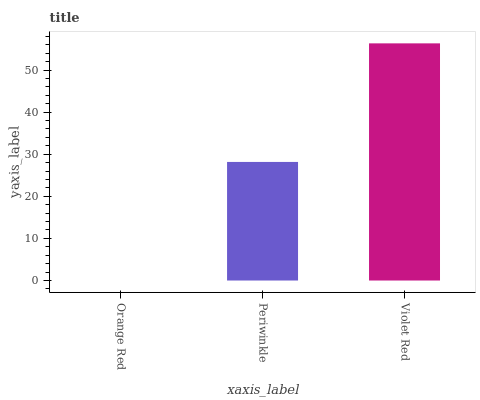Is Orange Red the minimum?
Answer yes or no. Yes. Is Violet Red the maximum?
Answer yes or no. Yes. Is Periwinkle the minimum?
Answer yes or no. No. Is Periwinkle the maximum?
Answer yes or no. No. Is Periwinkle greater than Orange Red?
Answer yes or no. Yes. Is Orange Red less than Periwinkle?
Answer yes or no. Yes. Is Orange Red greater than Periwinkle?
Answer yes or no. No. Is Periwinkle less than Orange Red?
Answer yes or no. No. Is Periwinkle the high median?
Answer yes or no. Yes. Is Periwinkle the low median?
Answer yes or no. Yes. Is Violet Red the high median?
Answer yes or no. No. Is Violet Red the low median?
Answer yes or no. No. 